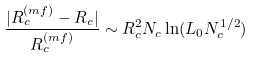<formula> <loc_0><loc_0><loc_500><loc_500>\frac { | R _ { c } ^ { ( m f ) } - R _ { c } | } { R _ { c } ^ { ( m f ) } } \sim R ^ { 2 } _ { c } N _ { c } \ln ( L _ { 0 } N ^ { 1 / 2 } _ { c } )</formula> 